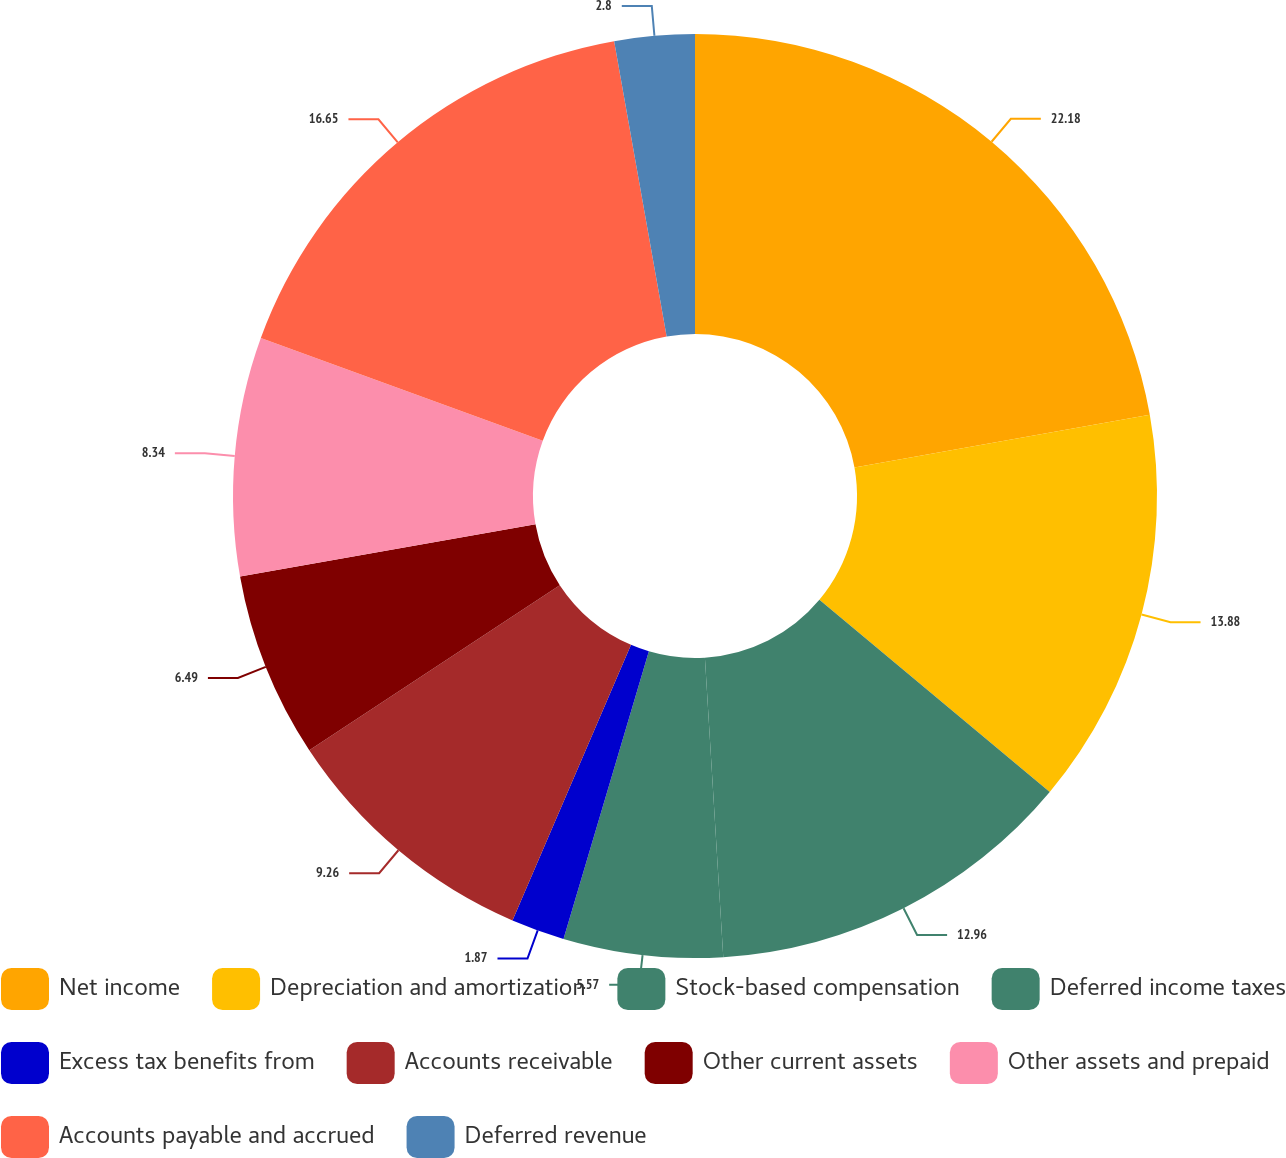<chart> <loc_0><loc_0><loc_500><loc_500><pie_chart><fcel>Net income<fcel>Depreciation and amortization<fcel>Stock-based compensation<fcel>Deferred income taxes<fcel>Excess tax benefits from<fcel>Accounts receivable<fcel>Other current assets<fcel>Other assets and prepaid<fcel>Accounts payable and accrued<fcel>Deferred revenue<nl><fcel>22.19%<fcel>13.88%<fcel>12.96%<fcel>5.57%<fcel>1.87%<fcel>9.26%<fcel>6.49%<fcel>8.34%<fcel>16.65%<fcel>2.8%<nl></chart> 